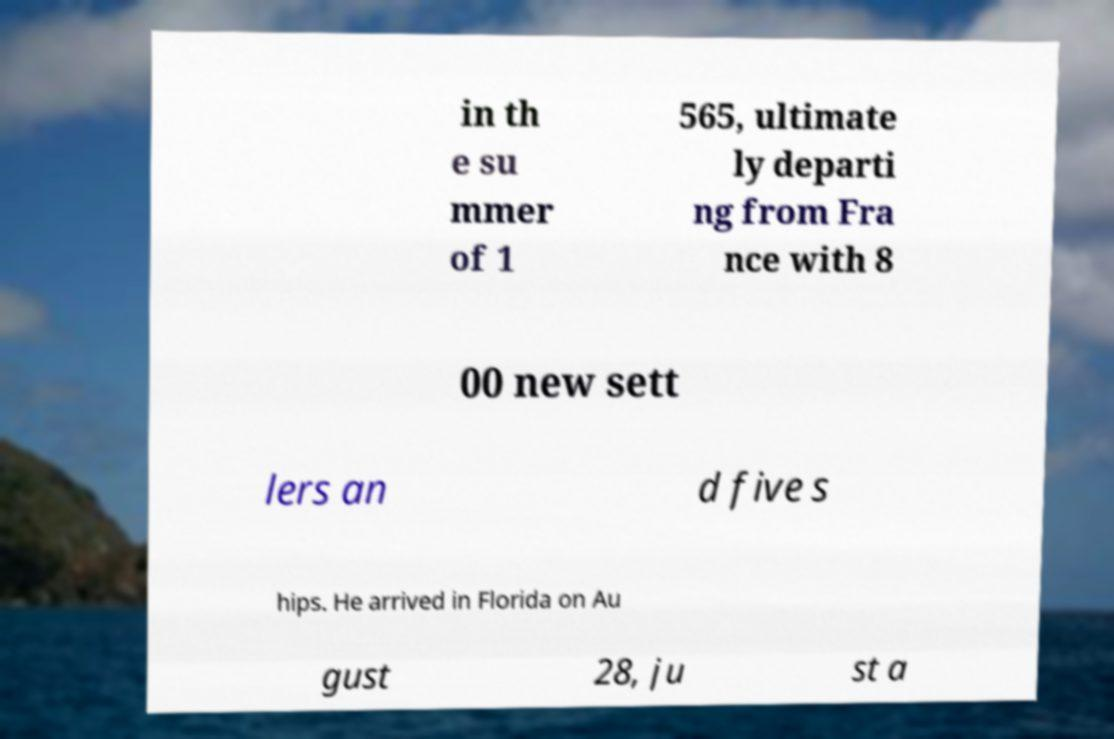There's text embedded in this image that I need extracted. Can you transcribe it verbatim? in th e su mmer of 1 565, ultimate ly departi ng from Fra nce with 8 00 new sett lers an d five s hips. He arrived in Florida on Au gust 28, ju st a 